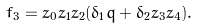Convert formula to latex. <formula><loc_0><loc_0><loc_500><loc_500>f _ { 3 } = z _ { 0 } z _ { 1 } z _ { 2 } ( \delta _ { 1 } q + \delta _ { 2 } z _ { 3 } z _ { 4 } ) .</formula> 